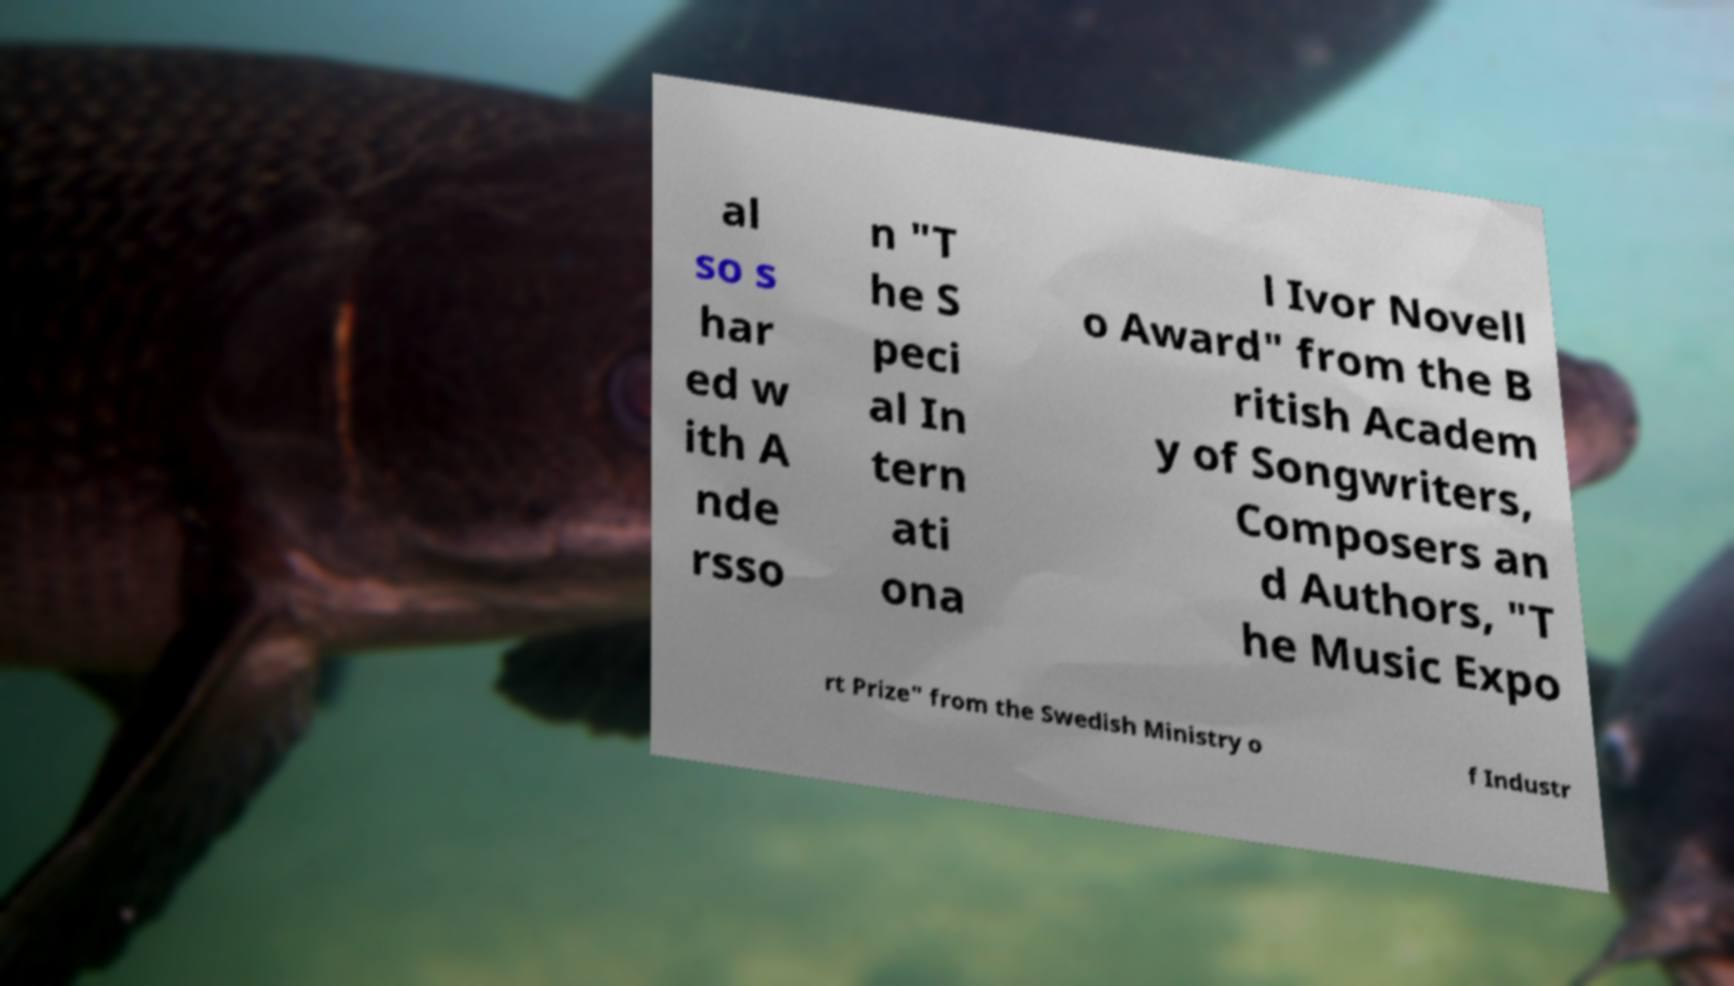Could you extract and type out the text from this image? al so s har ed w ith A nde rsso n "T he S peci al In tern ati ona l Ivor Novell o Award" from the B ritish Academ y of Songwriters, Composers an d Authors, "T he Music Expo rt Prize" from the Swedish Ministry o f Industr 